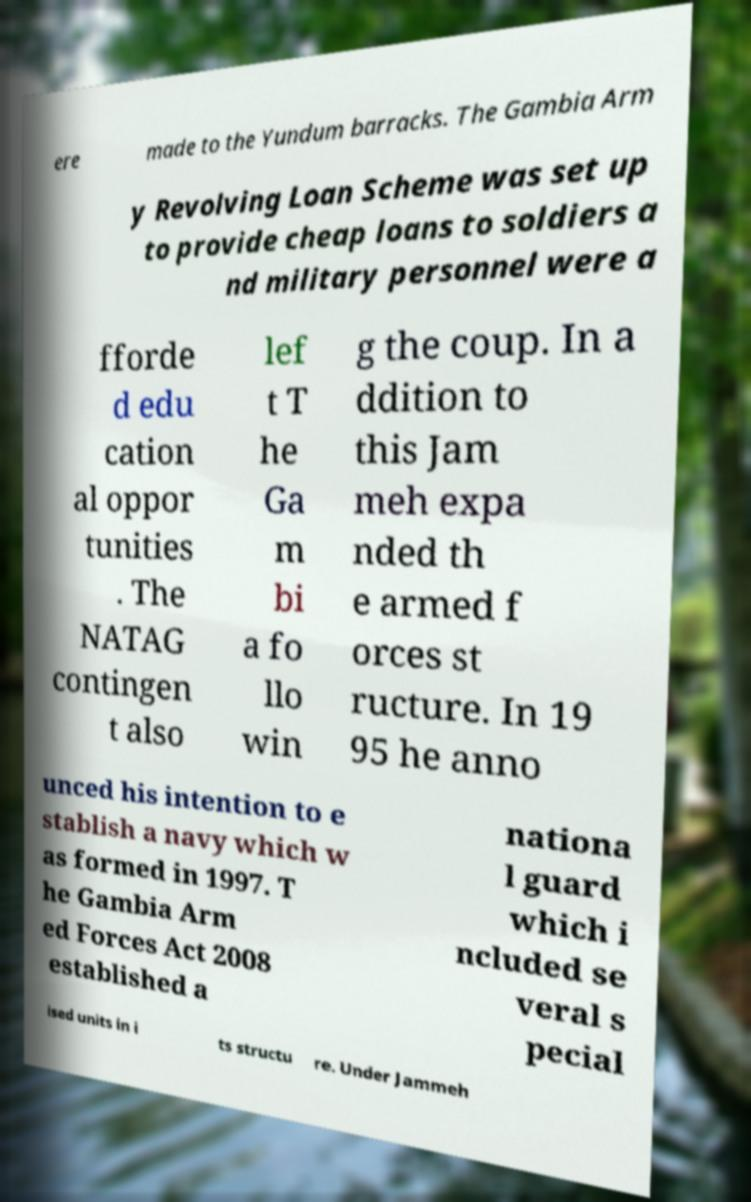I need the written content from this picture converted into text. Can you do that? ere made to the Yundum barracks. The Gambia Arm y Revolving Loan Scheme was set up to provide cheap loans to soldiers a nd military personnel were a fforde d edu cation al oppor tunities . The NATAG contingen t also lef t T he Ga m bi a fo llo win g the coup. In a ddition to this Jam meh expa nded th e armed f orces st ructure. In 19 95 he anno unced his intention to e stablish a navy which w as formed in 1997. T he Gambia Arm ed Forces Act 2008 established a nationa l guard which i ncluded se veral s pecial ised units in i ts structu re. Under Jammeh 